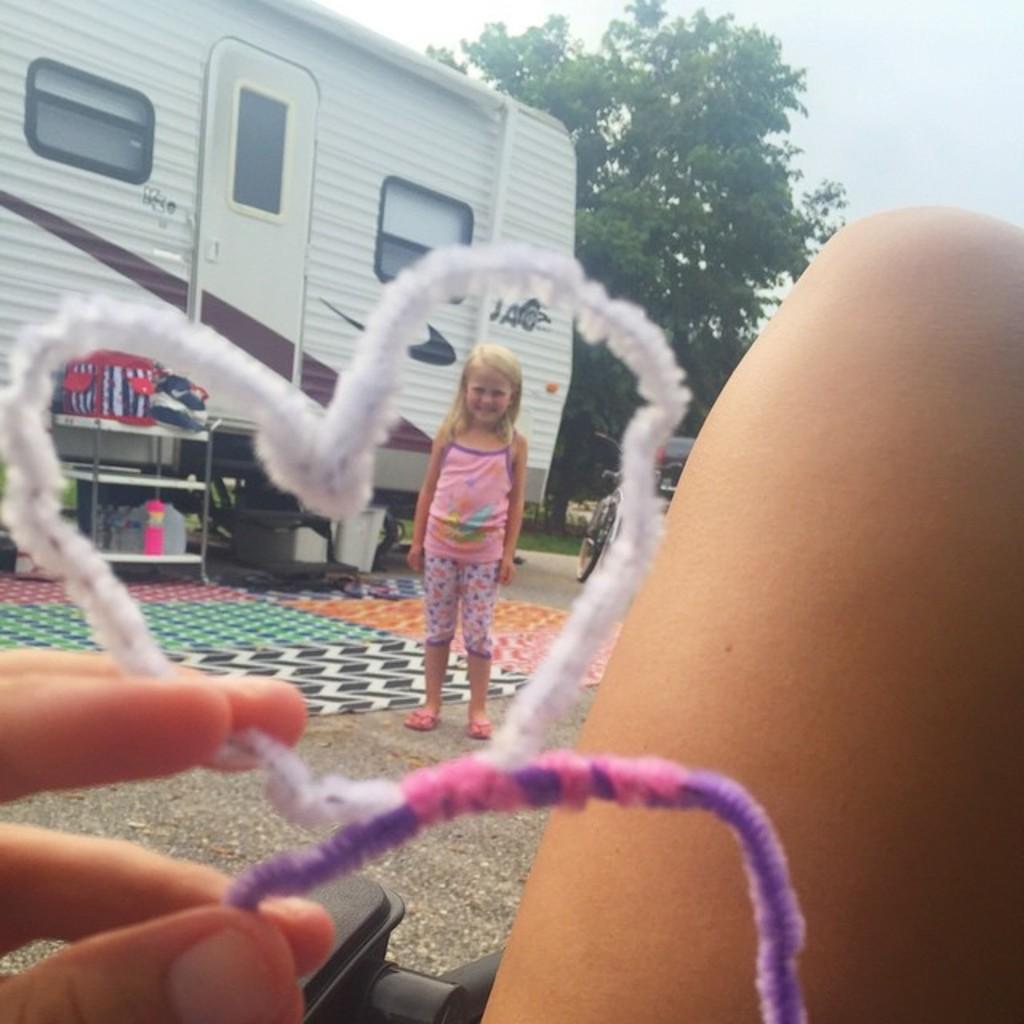How would you summarize this image in a sentence or two? As we can see in the image there are two people, tree, sky, bag, bottles, bicycle and building. 